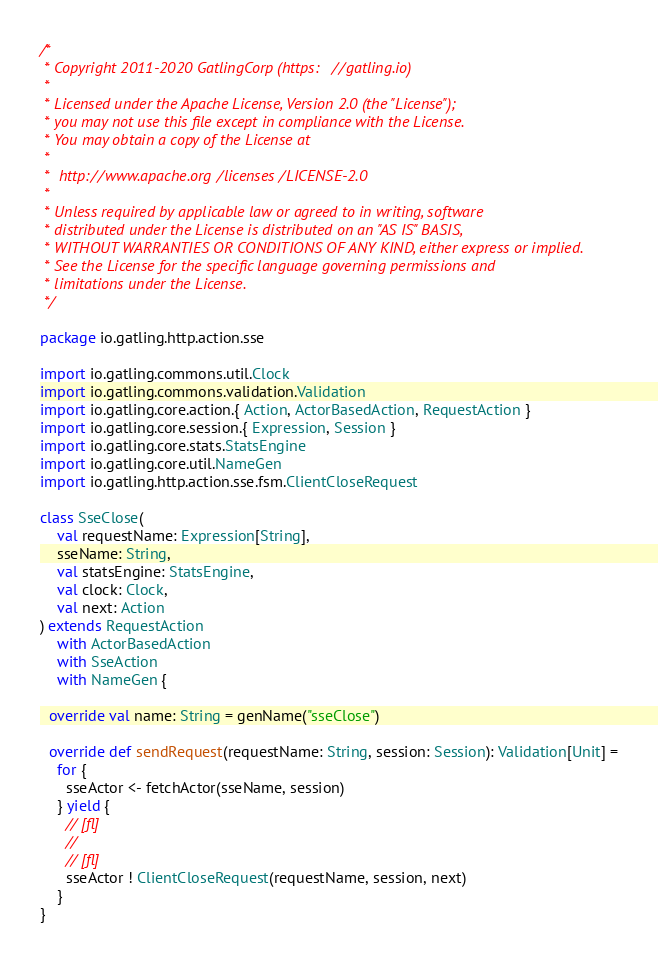<code> <loc_0><loc_0><loc_500><loc_500><_Scala_>/*
 * Copyright 2011-2020 GatlingCorp (https://gatling.io)
 *
 * Licensed under the Apache License, Version 2.0 (the "License");
 * you may not use this file except in compliance with the License.
 * You may obtain a copy of the License at
 *
 *  http://www.apache.org/licenses/LICENSE-2.0
 *
 * Unless required by applicable law or agreed to in writing, software
 * distributed under the License is distributed on an "AS IS" BASIS,
 * WITHOUT WARRANTIES OR CONDITIONS OF ANY KIND, either express or implied.
 * See the License for the specific language governing permissions and
 * limitations under the License.
 */

package io.gatling.http.action.sse

import io.gatling.commons.util.Clock
import io.gatling.commons.validation.Validation
import io.gatling.core.action.{ Action, ActorBasedAction, RequestAction }
import io.gatling.core.session.{ Expression, Session }
import io.gatling.core.stats.StatsEngine
import io.gatling.core.util.NameGen
import io.gatling.http.action.sse.fsm.ClientCloseRequest

class SseClose(
    val requestName: Expression[String],
    sseName: String,
    val statsEngine: StatsEngine,
    val clock: Clock,
    val next: Action
) extends RequestAction
    with ActorBasedAction
    with SseAction
    with NameGen {

  override val name: String = genName("sseClose")

  override def sendRequest(requestName: String, session: Session): Validation[Unit] =
    for {
      sseActor <- fetchActor(sseName, session)
    } yield {
      // [fl]
      //
      // [fl]
      sseActor ! ClientCloseRequest(requestName, session, next)
    }
}
</code> 